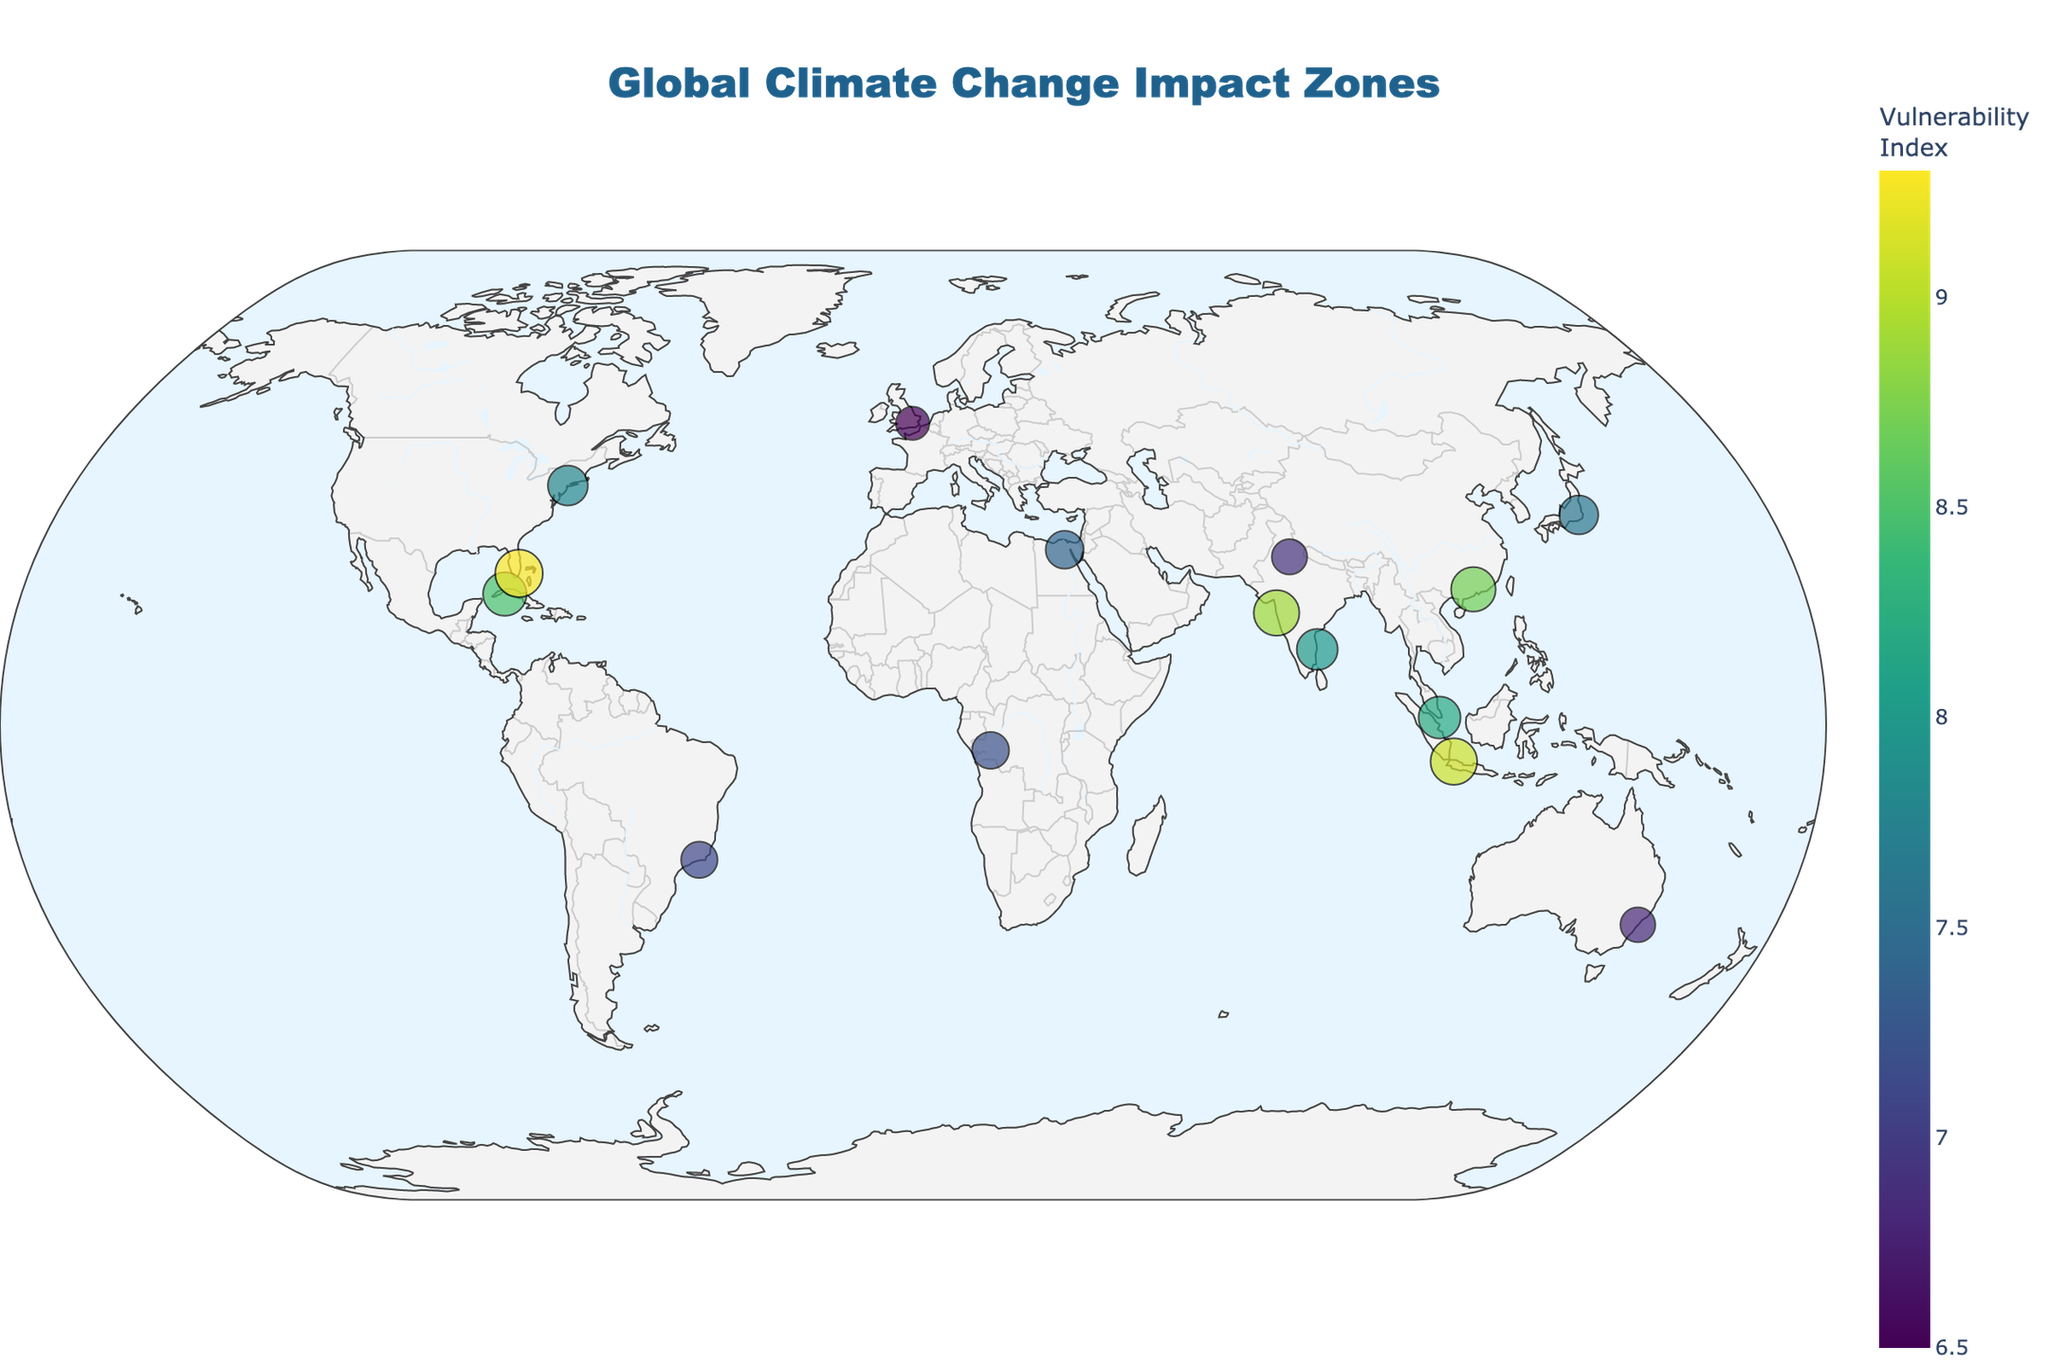What is the title of the plot? The title is a text element displayed at the top of the plot. It indicates the main theme or purpose of the visualization. In this case, it reads "Global Climate Change Impact Zones".
Answer: Global Climate Change Impact Zones How many locations are marked on the map? The number of locations marked on the map corresponds to the number of data points provided in the dataframe. By counting the distinct markers, we see there are 15 locations.
Answer: 15 Which location has the highest vulnerability index? To find the location with the highest vulnerability index, look for the marker that is largest in size and appears darkest in color on the color scale. Miami has the highest vulnerability index of 9.3.
Answer: Miami Which locations have a primary threat related to flooding? The locations with a primary threat related to flooding can be identified by examining the hover information for each marker. These include Singapore, Jakarta, Guangzhou, London, Kinshasa, and Mumbai.
Answer: Singapore, Jakarta, Guangzhou, London, Kinshasa, Mumbai What is the average vulnerability index of all the locations? Sum the vulnerability indices of all locations and divide by the number of locations. (8.5 + 7.8 + 8.2 + 6.9 + 9.1 + 7.6 + 9.3 + 8.7 + 6.5 + 6.8 + 8.0 + 7.2 + 8.9 + 7.4 + 7.1) / 15 = 7.8
Answer: 7.8 How does the marker size relate to the vulnerability index? The size of the markers on the map is directly proportional to the vulnerability index; larger markers indicate higher vulnerability indices.
Answer: Larger sizes indicate higher vulnerability Which regions have a vulnerability index greater than 8? Identifying regions with a vulnerability index greater than 8 involves examining the hover text of each marker. These regions are Havana, Singapore, Jakarta, Miami, Guangzhou, Chennai, and Mumbai.
Answer: Havana, Singapore, Jakarta, Miami, Guangzhou, Chennai, Mumbai What primary threat does Tokyo face according to the plot? Checking the hover information for the marker representing Tokyo reveals that its primary threat is typhoons.
Answer: Typhoons Which city has a lower vulnerability index, Cairo or Rio de Janeiro? By checking the hover information for both Cairo and Rio de Janeiro, we see that Cairo has a vulnerability index of 7.4, while Rio de Janeiro has an index of 7.1. Hence, Rio de Janeiro has a lower vulnerability index.
Answer: Rio de Janeiro What color represents regions with the lowest vulnerability index on the plot? The color representing regions with the lowest vulnerability index on the Viridis color scale is light yellow.
Answer: Light yellow 